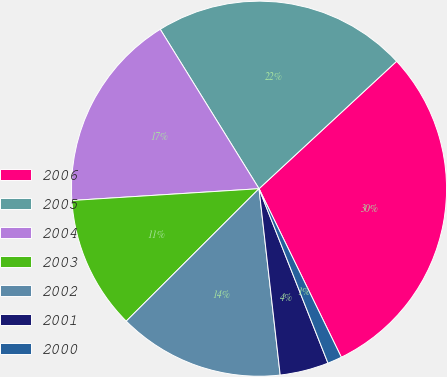<chart> <loc_0><loc_0><loc_500><loc_500><pie_chart><fcel>2006<fcel>2005<fcel>2004<fcel>2003<fcel>2002<fcel>2001<fcel>2000<nl><fcel>29.66%<fcel>21.94%<fcel>17.17%<fcel>11.48%<fcel>14.32%<fcel>4.19%<fcel>1.24%<nl></chart> 